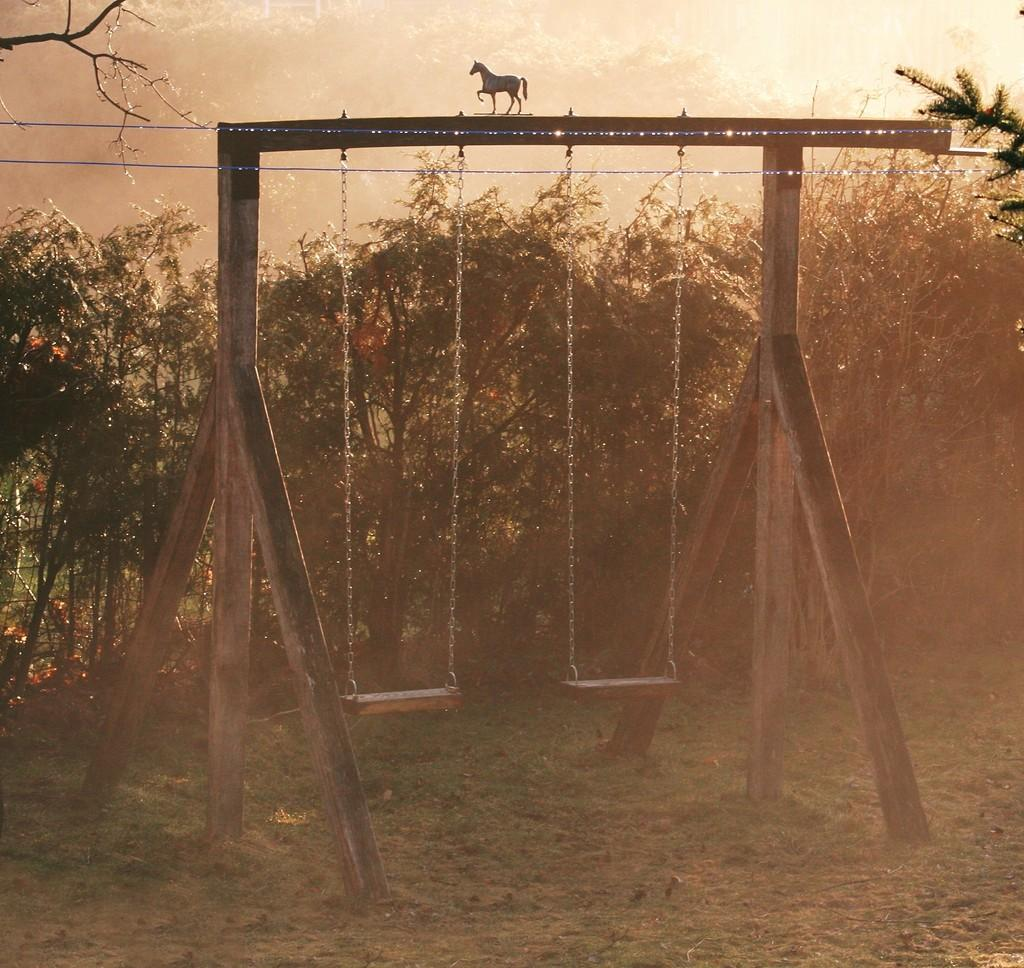What object is featured in the image? There is a doll horse in the image. How is the doll horse positioned? The doll horse is placed on a wooden swing. Where is the wooden swing located? The wooden swing is on the ground. What can be seen in the background of the image? There is a group of trees in the background of the image. What type of invention is being demonstrated by the doll horse in the image? There is no invention being demonstrated by the doll horse in the image; it is simply a doll horse placed on a wooden swing. 